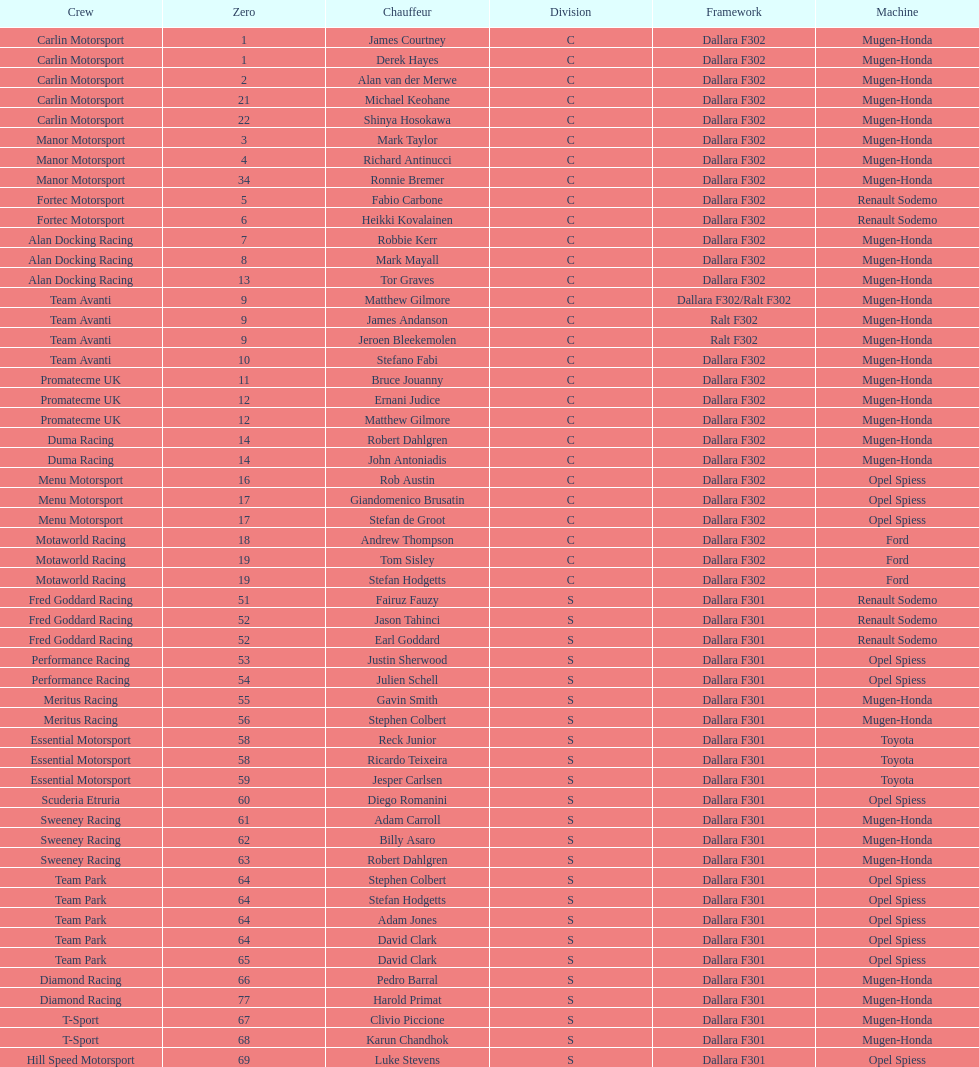What team is positioned above diamond racing? Team Park. 